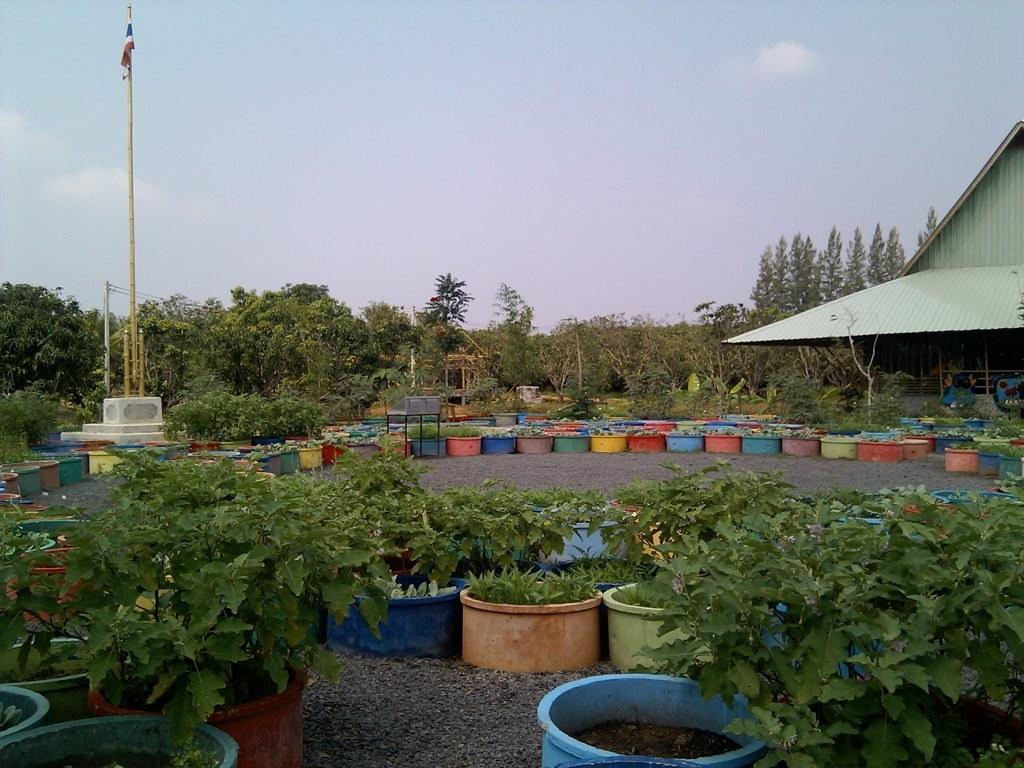What type of living organisms can be seen in the image? Plants and trees are visible in the image. What objects are used to hold the plants in the image? There are pots in the image that hold the plants. What is the purpose of the flag in the image? The purpose of the flag in the image is not specified, but it may represent a country, organization, or event. What type of structure is present in the image? There is a house in the image. What part of the natural environment is visible in the image? The sky is visible in the image. What type of rock is being used to knit a wool sweater in the image? There is no rock or wool sweater present in the image. What type of meeting is taking place in the image? There is no meeting present in the image. 